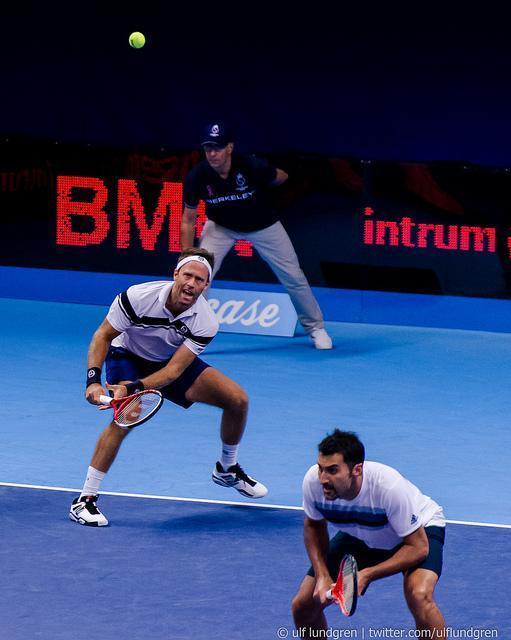How many people are wearing baseball caps?
Give a very brief answer. 1. How many feet are shown in this picture?
Give a very brief answer. 3. How many people are there?
Give a very brief answer. 2. 